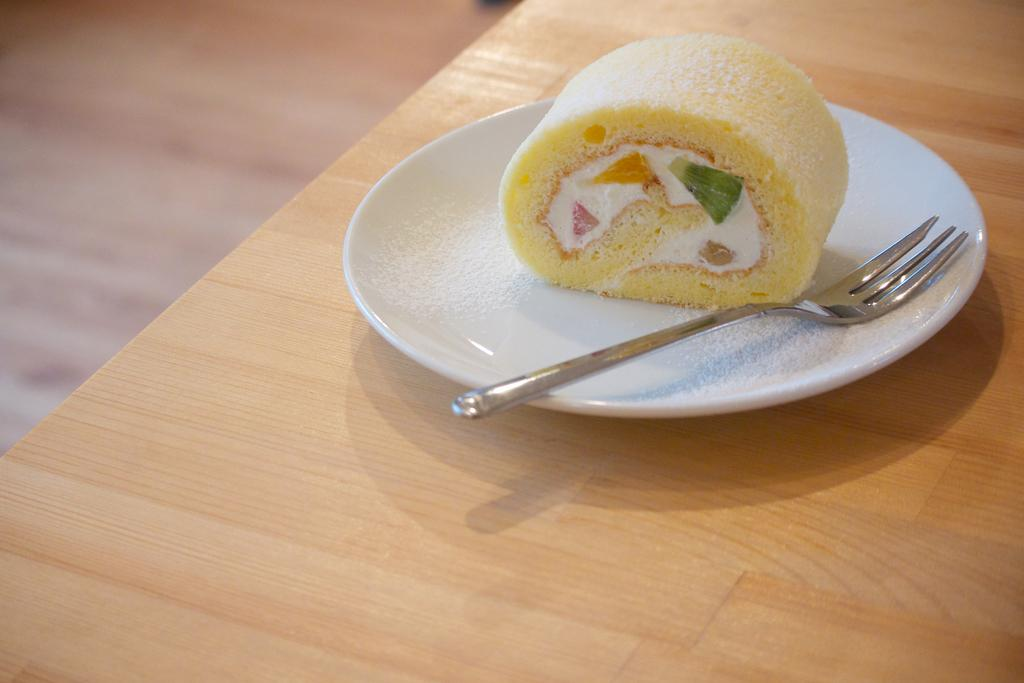What piece of furniture is present in the image? There is a table in the image. What is placed on the table? There is a plate on the table. What utensil is in the plate? There is a fork in the plate. What is the plate holding? There is food in the plate. Can you describe the background of the image? The background of the image is blurry. How do the sticks react to the rest in the image? There are no sticks or any reference to rest in the image. 